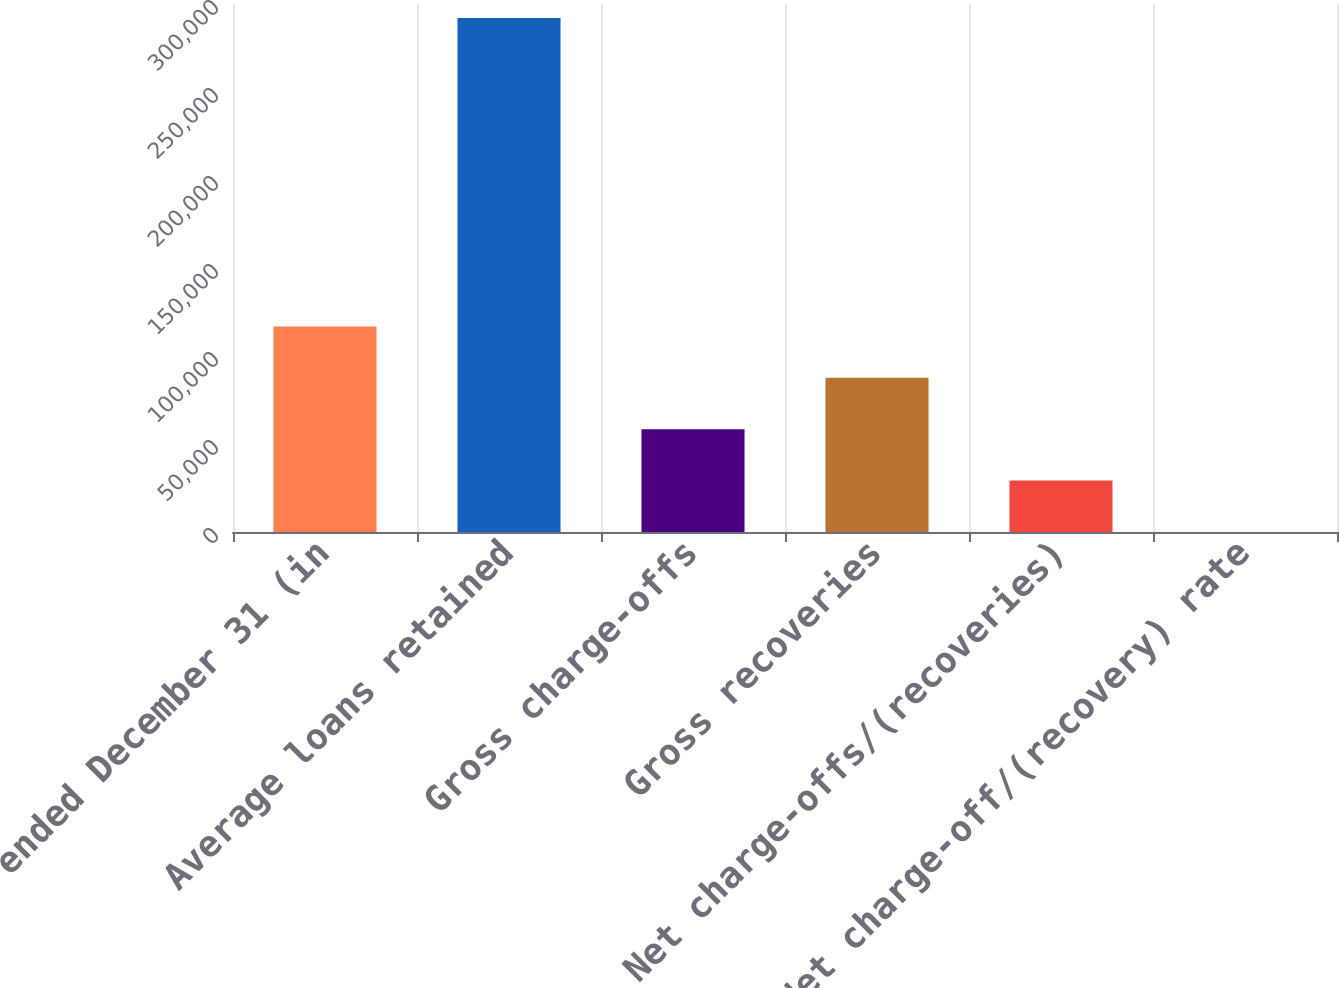<chart> <loc_0><loc_0><loc_500><loc_500><bar_chart><fcel>Year ended December 31 (in<fcel>Average loans retained<fcel>Gross charge-offs<fcel>Gross recoveries<fcel>Net charge-offs/(recoveries)<fcel>Net charge-off/(recovery) rate<nl><fcel>116792<fcel>291980<fcel>58396<fcel>87594<fcel>29198<fcel>0.06<nl></chart> 